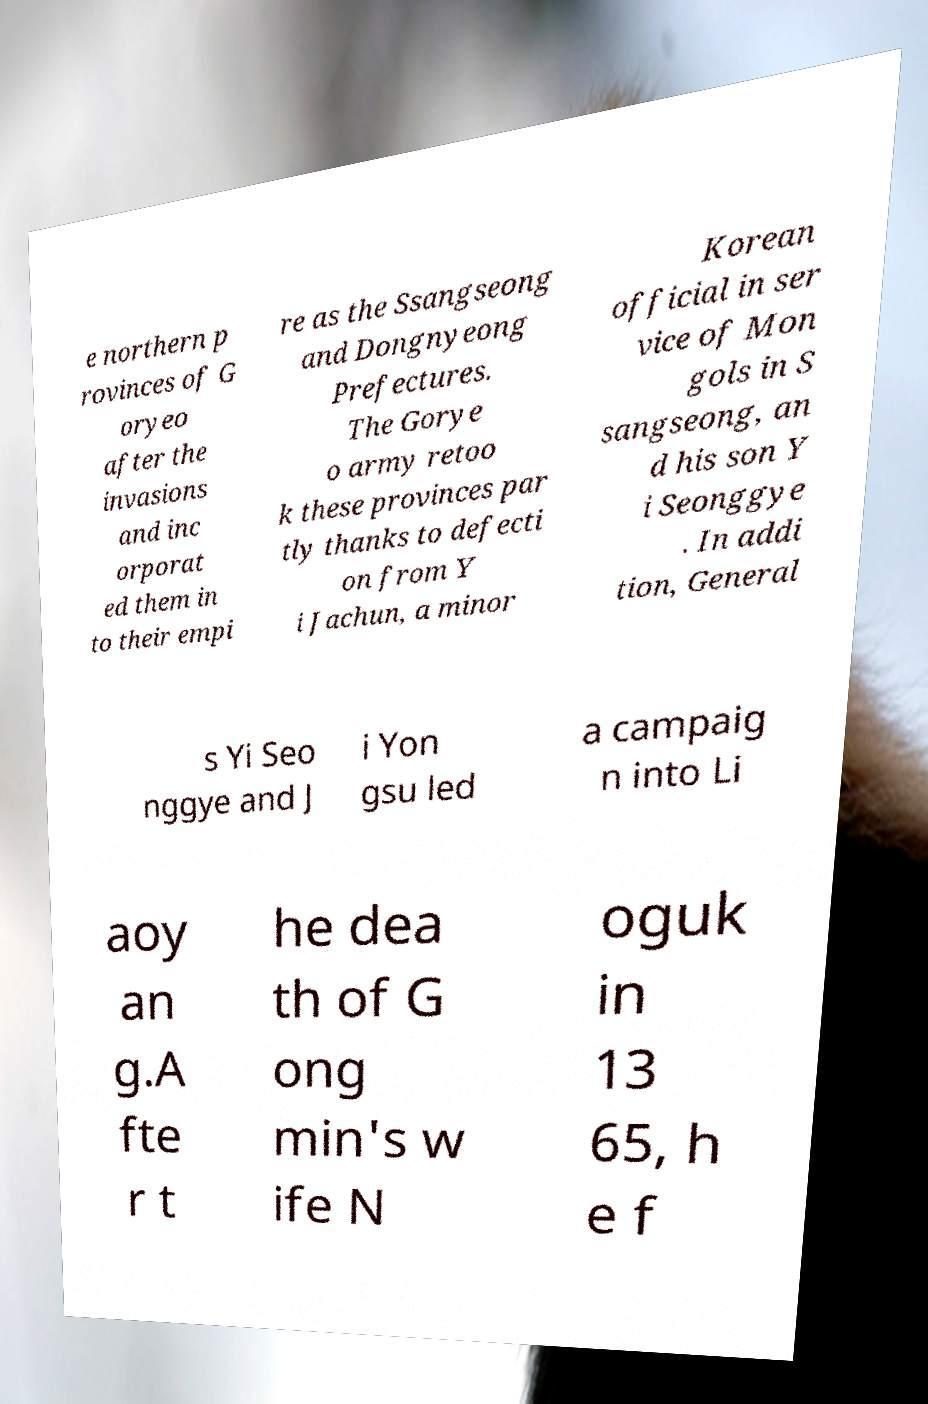Please read and relay the text visible in this image. What does it say? e northern p rovinces of G oryeo after the invasions and inc orporat ed them in to their empi re as the Ssangseong and Dongnyeong Prefectures. The Gorye o army retoo k these provinces par tly thanks to defecti on from Y i Jachun, a minor Korean official in ser vice of Mon gols in S sangseong, an d his son Y i Seonggye . In addi tion, General s Yi Seo nggye and J i Yon gsu led a campaig n into Li aoy an g.A fte r t he dea th of G ong min's w ife N oguk in 13 65, h e f 